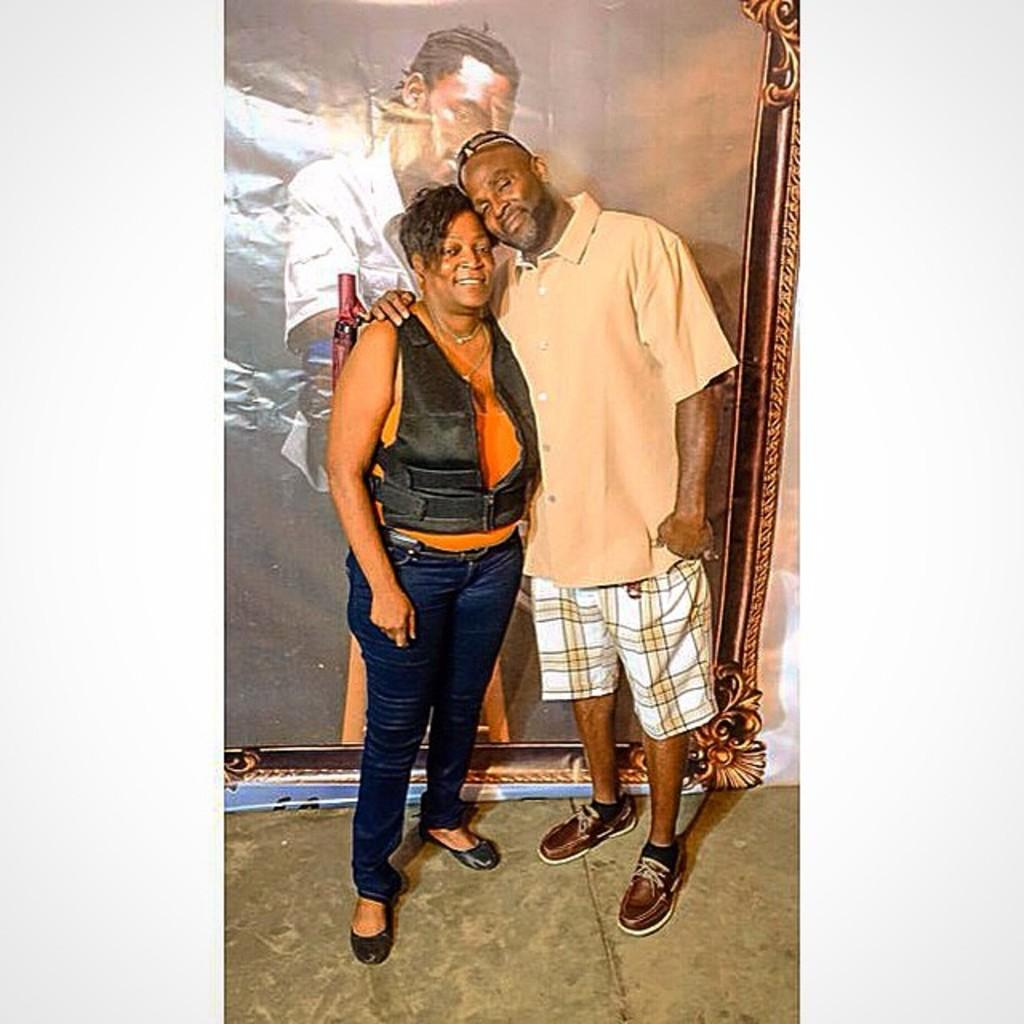Who are the people in the image? There is a man and a lady in the image. What are the man and lady doing in the image? The man and lady are standing. What can be seen in the background of the image? There is a board in the background of the image. What is visible at the bottom of the image? There is a floor visible at the bottom of the image. What type of brain can be seen in the image? There is no brain present in the image. What is the angle of the pail in the image? There is no pail present in the image. 